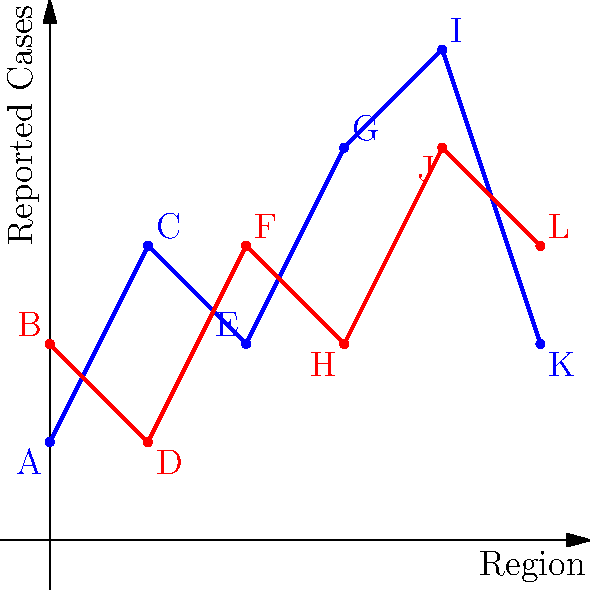As a prosecutor investigating the side effects of two drugs manufactured by different pharmaceutical companies, you're presented with a map showing the distribution of reported cases across six regions. The blue line represents Drug A, and the red line represents Drug B. Which drug shows a more concerning pattern of side effects, and what specific evidence supports your conclusion? To determine which drug shows a more concerning pattern of side effects, we need to analyze the distribution and severity of reported cases across the regions:

1. Analyze overall trend:
   - Drug A (blue): Shows an overall increasing trend with a peak in region 4.
   - Drug B (red): Shows a more stable pattern with less variation.

2. Compare severity:
   - Drug A has higher peaks, reaching 5 reported cases in region 4.
   - Drug B's highest point is 4 reported cases in region 4.

3. Examine consistency:
   - Drug A shows more variability, with reported cases ranging from 1 to 5.
   - Drug B is more consistent, with reported cases ranging from 1 to 4.

4. Analyze regional impact:
   - Drug A affects some regions more severely (e.g., regions 3 and 4).
   - Drug B has a more uniform impact across regions.

5. Consider total reported cases:
   - Drug A: 1 + 3 + 2 + 4 + 5 + 2 = 17 total cases
   - Drug B: 2 + 1 + 3 + 2 + 4 + 3 = 15 total cases

6. Legal implications:
   - Drug A's pattern suggests potentially more severe and localized effects, which could indicate a failure to warn or inadequate testing in specific populations.
   - Drug B's pattern, while slightly lower in total cases, shows a more consistent risk across regions.

Conclusion: Drug A shows a more concerning pattern of side effects due to its higher variability, more severe peaks, and greater total number of reported cases. This pattern suggests a potentially more dangerous and unpredictable risk profile, which could be grounds for stronger legal action against its manufacturer.
Answer: Drug A, due to higher variability, severity, and total cases. 